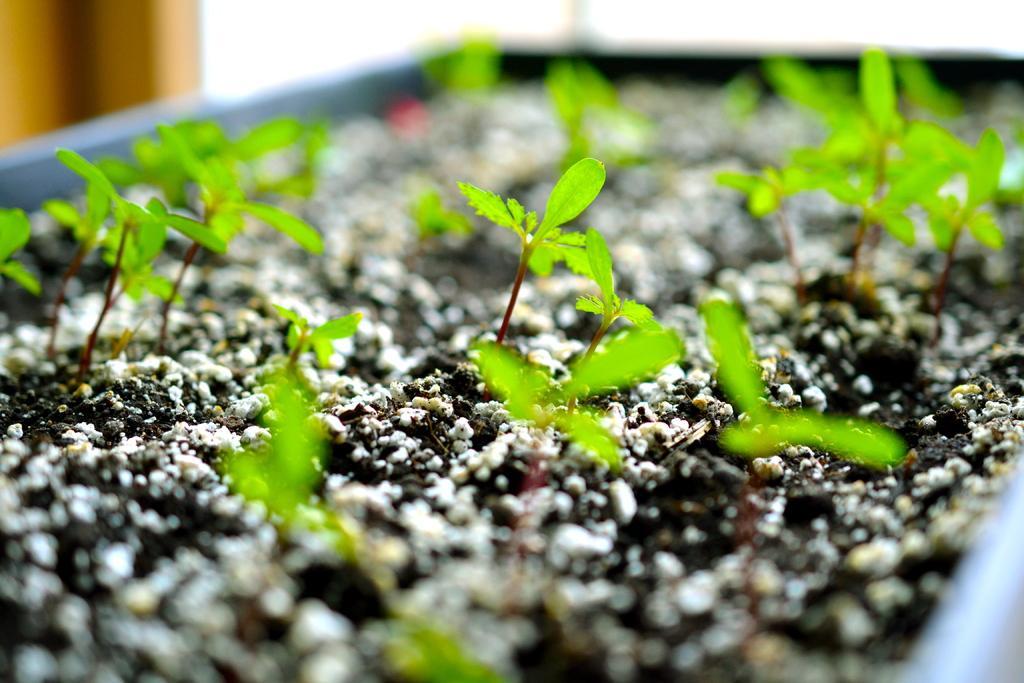Describe this image in one or two sentences. In the center of the image there is a flower pot and we can see seedlings in the pot. 